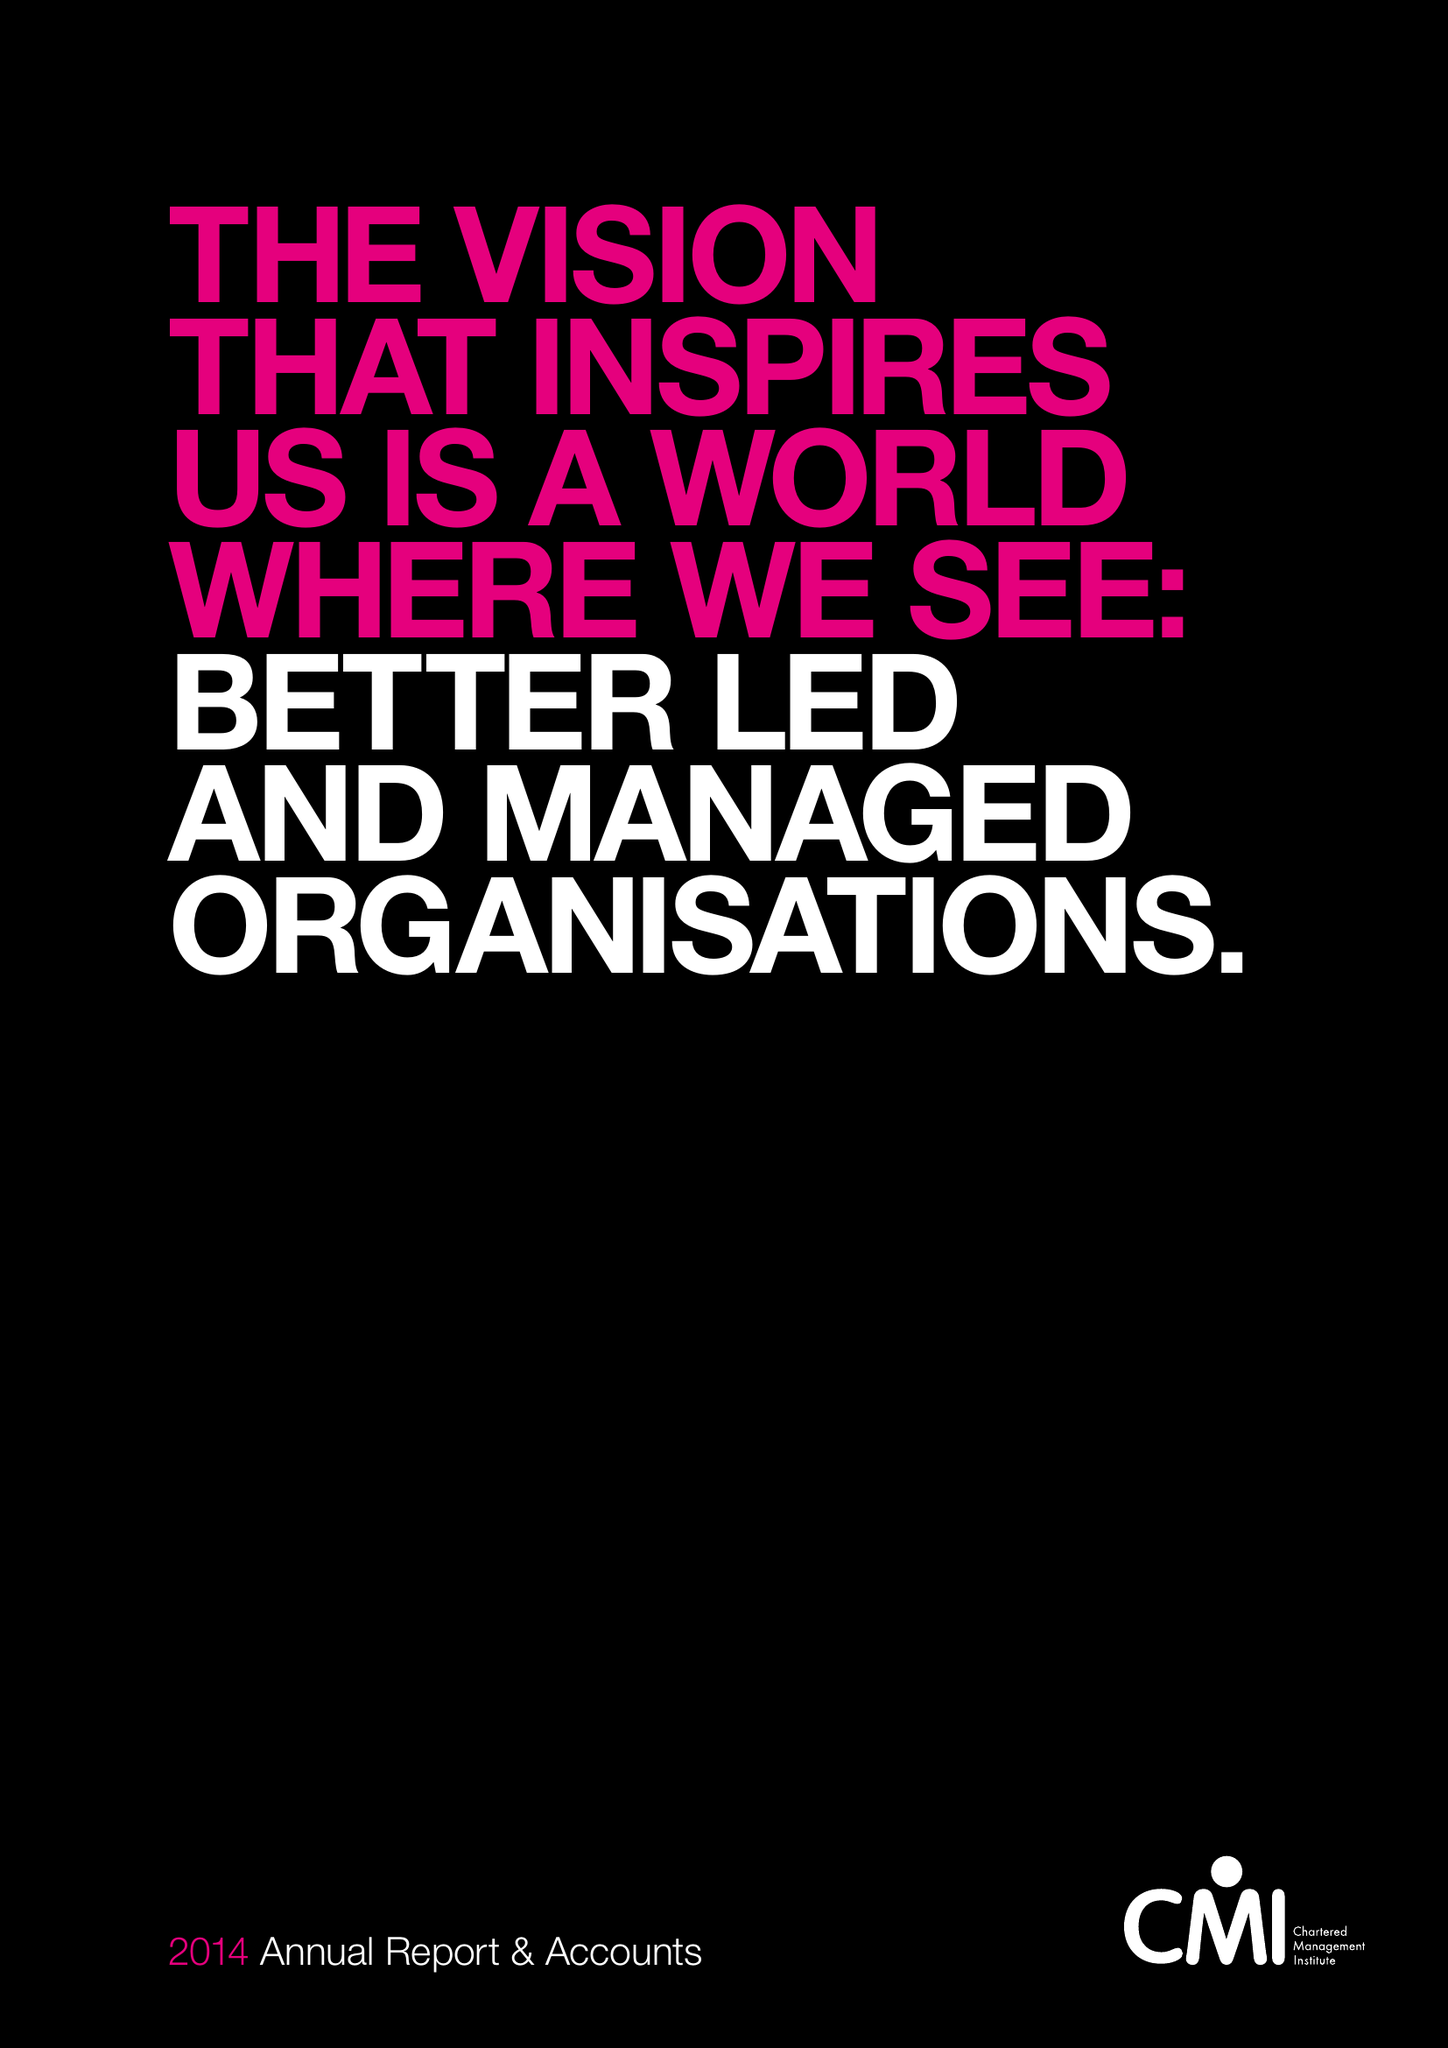What is the value for the report_date?
Answer the question using a single word or phrase. 2014-03-31 